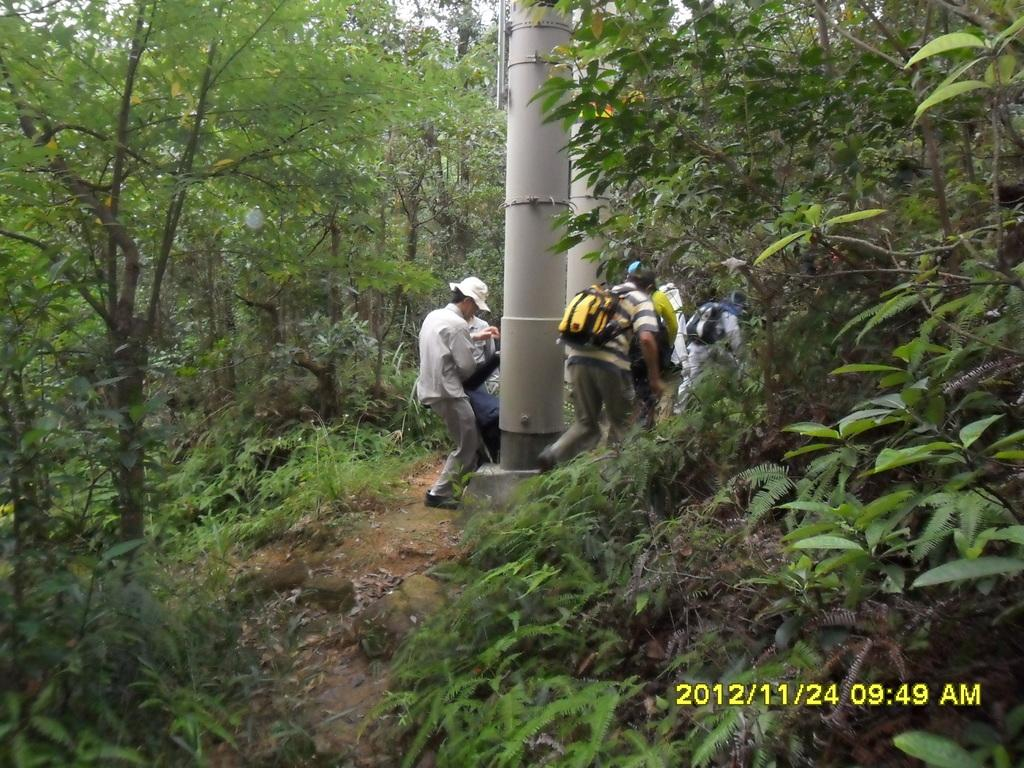Who or what can be seen in the image? There are people in the image. What is the pillar-like object on the floor? There is a pillar-like object on the floor in the image. What type of natural elements are present in the image? There are trees and plants in the image. Can you tell me how many trays are being carried by the people in the image? There is no mention of trays in the image, so it is not possible to determine how many trays are being carried. 